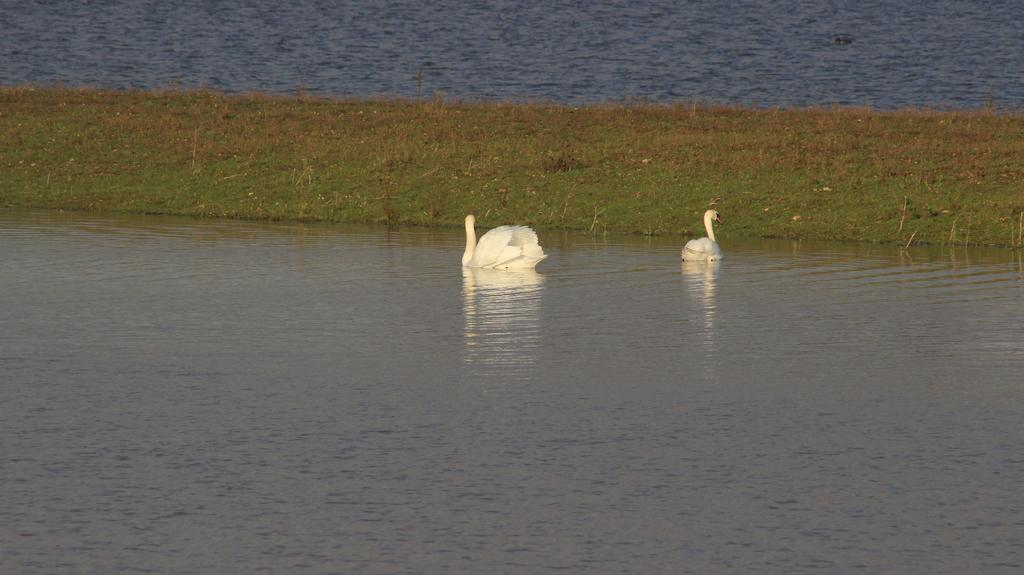What animals can be seen in the image? There are swans in the image. Where are the swans located? The swans are on the water surface. What type of landscape is visible in the image? There is a grassland in the image. What type of lace can be seen on the swans in the image? There is no lace present on the swans in the image. What kind of cheese is being stored in the jar visible in the image? There is no jar or cheese present in the image. 